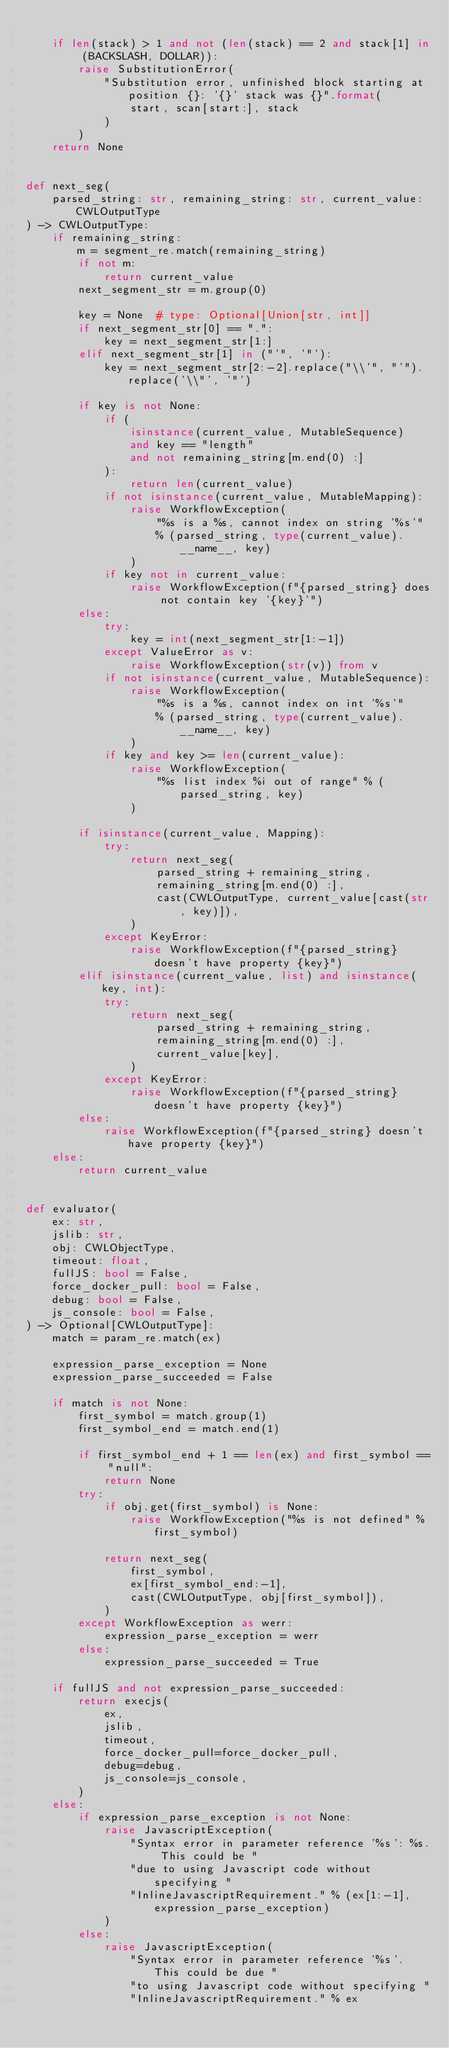<code> <loc_0><loc_0><loc_500><loc_500><_Python_>
    if len(stack) > 1 and not (len(stack) == 2 and stack[1] in (BACKSLASH, DOLLAR)):
        raise SubstitutionError(
            "Substitution error, unfinished block starting at position {}: '{}' stack was {}".format(
                start, scan[start:], stack
            )
        )
    return None


def next_seg(
    parsed_string: str, remaining_string: str, current_value: CWLOutputType
) -> CWLOutputType:
    if remaining_string:
        m = segment_re.match(remaining_string)
        if not m:
            return current_value
        next_segment_str = m.group(0)

        key = None  # type: Optional[Union[str, int]]
        if next_segment_str[0] == ".":
            key = next_segment_str[1:]
        elif next_segment_str[1] in ("'", '"'):
            key = next_segment_str[2:-2].replace("\\'", "'").replace('\\"', '"')

        if key is not None:
            if (
                isinstance(current_value, MutableSequence)
                and key == "length"
                and not remaining_string[m.end(0) :]
            ):
                return len(current_value)
            if not isinstance(current_value, MutableMapping):
                raise WorkflowException(
                    "%s is a %s, cannot index on string '%s'"
                    % (parsed_string, type(current_value).__name__, key)
                )
            if key not in current_value:
                raise WorkflowException(f"{parsed_string} does not contain key '{key}'")
        else:
            try:
                key = int(next_segment_str[1:-1])
            except ValueError as v:
                raise WorkflowException(str(v)) from v
            if not isinstance(current_value, MutableSequence):
                raise WorkflowException(
                    "%s is a %s, cannot index on int '%s'"
                    % (parsed_string, type(current_value).__name__, key)
                )
            if key and key >= len(current_value):
                raise WorkflowException(
                    "%s list index %i out of range" % (parsed_string, key)
                )

        if isinstance(current_value, Mapping):
            try:
                return next_seg(
                    parsed_string + remaining_string,
                    remaining_string[m.end(0) :],
                    cast(CWLOutputType, current_value[cast(str, key)]),
                )
            except KeyError:
                raise WorkflowException(f"{parsed_string} doesn't have property {key}")
        elif isinstance(current_value, list) and isinstance(key, int):
            try:
                return next_seg(
                    parsed_string + remaining_string,
                    remaining_string[m.end(0) :],
                    current_value[key],
                )
            except KeyError:
                raise WorkflowException(f"{parsed_string} doesn't have property {key}")
        else:
            raise WorkflowException(f"{parsed_string} doesn't have property {key}")
    else:
        return current_value


def evaluator(
    ex: str,
    jslib: str,
    obj: CWLObjectType,
    timeout: float,
    fullJS: bool = False,
    force_docker_pull: bool = False,
    debug: bool = False,
    js_console: bool = False,
) -> Optional[CWLOutputType]:
    match = param_re.match(ex)

    expression_parse_exception = None
    expression_parse_succeeded = False

    if match is not None:
        first_symbol = match.group(1)
        first_symbol_end = match.end(1)

        if first_symbol_end + 1 == len(ex) and first_symbol == "null":
            return None
        try:
            if obj.get(first_symbol) is None:
                raise WorkflowException("%s is not defined" % first_symbol)

            return next_seg(
                first_symbol,
                ex[first_symbol_end:-1],
                cast(CWLOutputType, obj[first_symbol]),
            )
        except WorkflowException as werr:
            expression_parse_exception = werr
        else:
            expression_parse_succeeded = True

    if fullJS and not expression_parse_succeeded:
        return execjs(
            ex,
            jslib,
            timeout,
            force_docker_pull=force_docker_pull,
            debug=debug,
            js_console=js_console,
        )
    else:
        if expression_parse_exception is not None:
            raise JavascriptException(
                "Syntax error in parameter reference '%s': %s. This could be "
                "due to using Javascript code without specifying "
                "InlineJavascriptRequirement." % (ex[1:-1], expression_parse_exception)
            )
        else:
            raise JavascriptException(
                "Syntax error in parameter reference '%s'. This could be due "
                "to using Javascript code without specifying "
                "InlineJavascriptRequirement." % ex</code> 